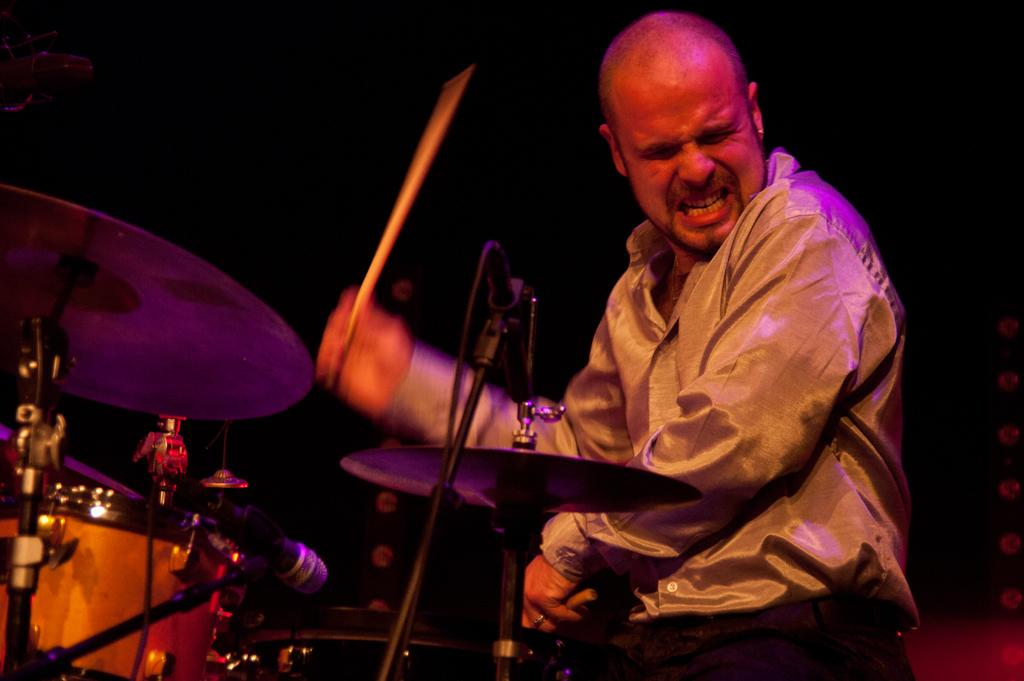What is the man in the image doing? The man is playing drums. What object is present in the image that is commonly used for amplifying sound? There is a microphone (mike) in the image. What historical discovery can be seen in the image? There is no historical discovery present in the image; it features a man playing drums and a microphone. How many ploughs are visible in the image? There are no ploughs present in the image. 